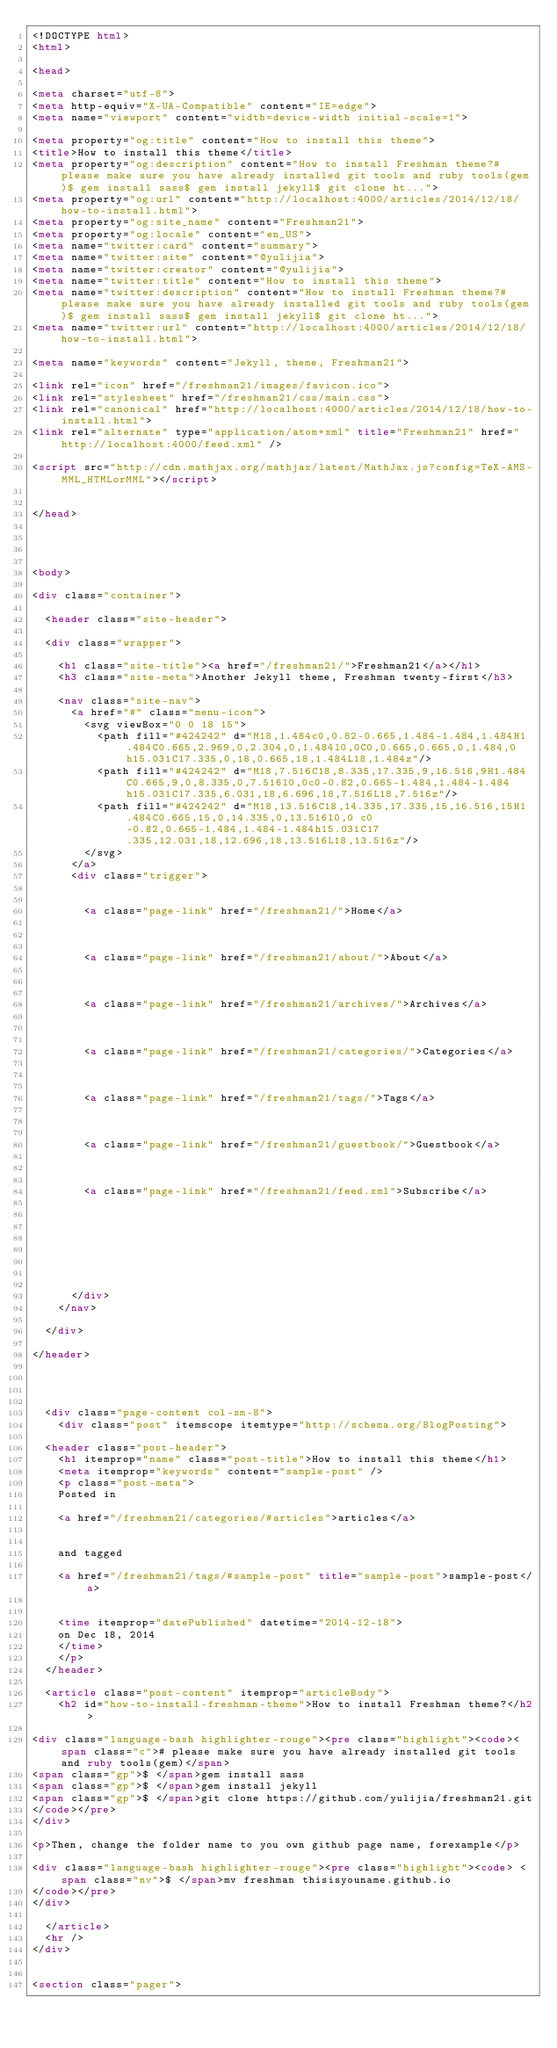Convert code to text. <code><loc_0><loc_0><loc_500><loc_500><_HTML_><!DOCTYPE html>
<html>

<head>

<meta charset="utf-8">
<meta http-equiv="X-UA-Compatible" content="IE=edge">
<meta name="viewport" content="width=device-width initial-scale=1">

<meta property="og:title" content="How to install this theme">
<title>How to install this theme</title>
<meta property="og:description" content="How to install Freshman theme?# please make sure you have already installed git tools and ruby tools(gem)$ gem install sass$ gem install jekyll$ git clone ht...">
<meta property="og:url" content="http://localhost:4000/articles/2014/12/18/how-to-install.html">
<meta property="og:site_name" content="Freshman21">
<meta property="og:locale" content="en_US">
<meta name="twitter:card" content="summary">
<meta name="twitter:site" content="@yulijia">
<meta name="twitter:creator" content="@yulijia">
<meta name="twitter:title" content="How to install this theme">
<meta name="twitter:description" content="How to install Freshman theme?# please make sure you have already installed git tools and ruby tools(gem)$ gem install sass$ gem install jekyll$ git clone ht...">
<meta name="twitter:url" content="http://localhost:4000/articles/2014/12/18/how-to-install.html">

<meta name="keywords" content="Jekyll, theme, Freshman21">

<link rel="icon" href="/freshman21/images/favicon.ico">
<link rel="stylesheet" href="/freshman21/css/main.css">
<link rel="canonical" href="http://localhost:4000/articles/2014/12/18/how-to-install.html">
<link rel="alternate" type="application/atom+xml" title="Freshman21" href="http://localhost:4000/feed.xml" />

<script src="http://cdn.mathjax.org/mathjax/latest/MathJax.js?config=TeX-AMS-MML_HTMLorMML"></script>


</head>




<body>

<div class="container">

  <header class="site-header">

  <div class="wrapper">

    <h1 class="site-title"><a href="/freshman21/">Freshman21</a></h1>
    <h3 class="site-meta">Another Jekyll theme, Freshman twenty-first</h3>

    <nav class="site-nav">
      <a href="#" class="menu-icon">
        <svg viewBox="0 0 18 15">
          <path fill="#424242" d="M18,1.484c0,0.82-0.665,1.484-1.484,1.484H1.484C0.665,2.969,0,2.304,0,1.484l0,0C0,0.665,0.665,0,1.484,0 h15.031C17.335,0,18,0.665,18,1.484L18,1.484z"/>
          <path fill="#424242" d="M18,7.516C18,8.335,17.335,9,16.516,9H1.484C0.665,9,0,8.335,0,7.516l0,0c0-0.82,0.665-1.484,1.484-1.484 h15.031C17.335,6.031,18,6.696,18,7.516L18,7.516z"/>
          <path fill="#424242" d="M18,13.516C18,14.335,17.335,15,16.516,15H1.484C0.665,15,0,14.335,0,13.516l0,0 c0-0.82,0.665-1.484,1.484-1.484h15.031C17.335,12.031,18,12.696,18,13.516L18,13.516z"/>
        </svg>
      </a>
      <div class="trigger">
        
        
        <a class="page-link" href="/freshman21/">Home</a>
        
        
        
        <a class="page-link" href="/freshman21/about/">About</a>
        
        
        
        <a class="page-link" href="/freshman21/archives/">Archives</a>
        
        
        
        <a class="page-link" href="/freshman21/categories/">Categories</a>
        
        
        
        <a class="page-link" href="/freshman21/tags/">Tags</a>
        
        
        
        <a class="page-link" href="/freshman21/guestbook/">Guestbook</a>
        
        
        
        <a class="page-link" href="/freshman21/feed.xml">Subscribe</a>
        
        
        
        
        
        
        
        
      </div>
    </nav>

  </div>

</header>


    

  <div class="page-content col-sm-8">
    <div class="post" itemscope itemtype="http://schema.org/BlogPosting">

  <header class="post-header">
    <h1 itemprop="name" class="post-title">How to install this theme</h1>
    <meta itemprop="keywords" content="sample-post" />
    <p class="post-meta">
    Posted in
    
    <a href="/freshman21/categories/#articles">articles</a>
     
    
    and tagged
    
    <a href="/freshman21/tags/#sample-post" title="sample-post">sample-post</a>
    
    
    <time itemprop="datePublished" datetime="2014-12-18">
    on Dec 18, 2014
    </time>
    </p>
  </header>

  <article class="post-content" itemprop="articleBody">
    <h2 id="how-to-install-freshman-theme">How to install Freshman theme?</h2>

<div class="language-bash highlighter-rouge"><pre class="highlight"><code><span class="c"># please make sure you have already installed git tools and ruby tools(gem)</span>
<span class="gp">$ </span>gem install sass
<span class="gp">$ </span>gem install jekyll
<span class="gp">$ </span>git clone https://github.com/yulijia/freshman21.git
</code></pre>
</div>

<p>Then, change the folder name to you own github page name, forexample</p>

<div class="language-bash highlighter-rouge"><pre class="highlight"><code> <span class="nv">$ </span>mv freshman thisisyouname.github.io
</code></pre>
</div>

  </article>
  <hr />
</div>


<section class="pager"></code> 